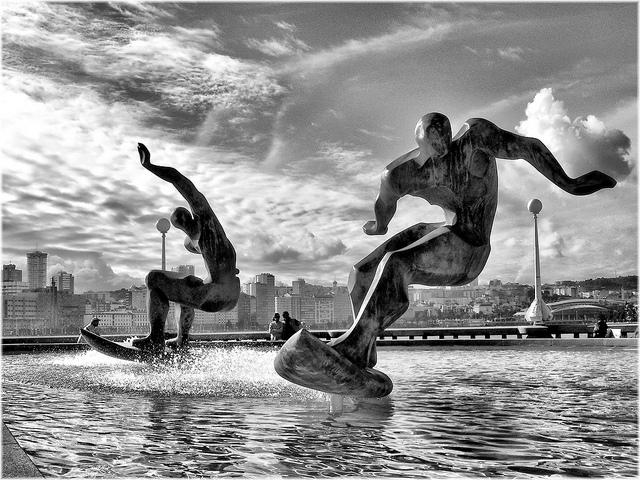What energy powers the splash? water 